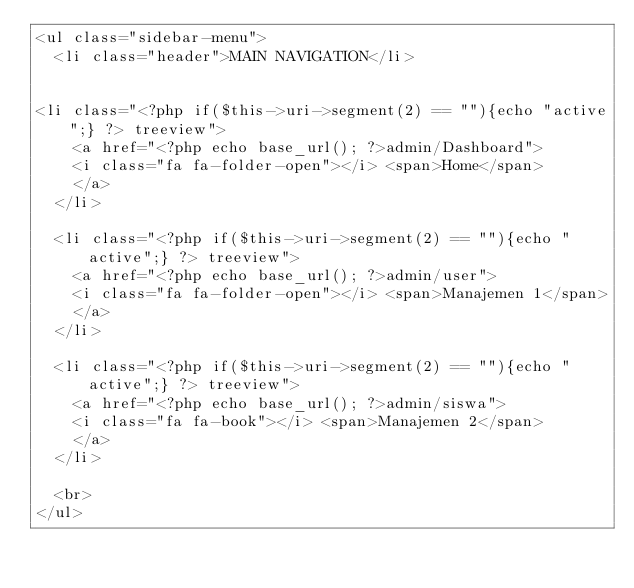Convert code to text. <code><loc_0><loc_0><loc_500><loc_500><_PHP_><ul class="sidebar-menu">
  <li class="header">MAIN NAVIGATION</li>


<li class="<?php if($this->uri->segment(2) == ""){echo "active";} ?> treeview">
    <a href="<?php echo base_url(); ?>admin/Dashboard">
    <i class="fa fa-folder-open"></i> <span>Home</span>
    </a>
  </li>

  <li class="<?php if($this->uri->segment(2) == ""){echo "active";} ?> treeview">
    <a href="<?php echo base_url(); ?>admin/user">
    <i class="fa fa-folder-open"></i> <span>Manajemen 1</span>
    </a>
  </li>

  <li class="<?php if($this->uri->segment(2) == ""){echo "active";} ?> treeview">
    <a href="<?php echo base_url(); ?>admin/siswa">
    <i class="fa fa-book"></i> <span>Manajemen 2</span>
    </a>
  </li>

  <br>
</ul>

</code> 